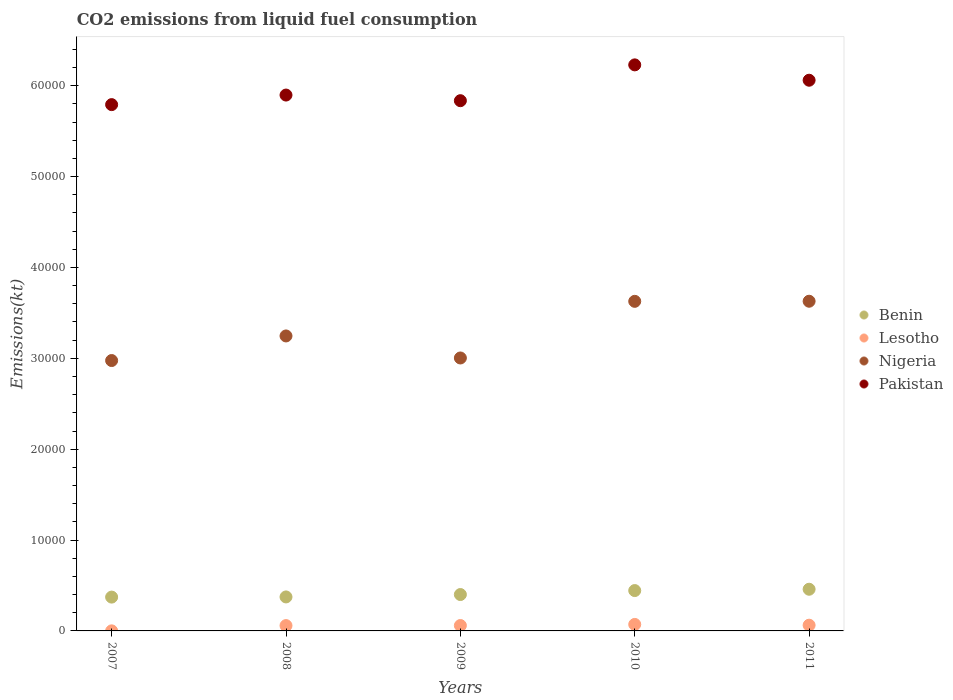How many different coloured dotlines are there?
Offer a very short reply. 4. Is the number of dotlines equal to the number of legend labels?
Offer a very short reply. Yes. What is the amount of CO2 emitted in Benin in 2011?
Give a very brief answer. 4587.42. Across all years, what is the maximum amount of CO2 emitted in Benin?
Keep it short and to the point. 4587.42. Across all years, what is the minimum amount of CO2 emitted in Benin?
Your answer should be compact. 3722.01. In which year was the amount of CO2 emitted in Nigeria maximum?
Offer a very short reply. 2011. What is the total amount of CO2 emitted in Benin in the graph?
Offer a terse response. 2.05e+04. What is the difference between the amount of CO2 emitted in Nigeria in 2009 and that in 2010?
Provide a short and direct response. -6233.9. What is the difference between the amount of CO2 emitted in Benin in 2010 and the amount of CO2 emitted in Nigeria in 2008?
Ensure brevity in your answer.  -2.80e+04. What is the average amount of CO2 emitted in Lesotho per year?
Provide a succinct answer. 506.78. In the year 2011, what is the difference between the amount of CO2 emitted in Nigeria and amount of CO2 emitted in Benin?
Your answer should be compact. 3.17e+04. In how many years, is the amount of CO2 emitted in Pakistan greater than 32000 kt?
Provide a succinct answer. 5. What is the ratio of the amount of CO2 emitted in Benin in 2007 to that in 2008?
Provide a short and direct response. 1. Is the difference between the amount of CO2 emitted in Nigeria in 2008 and 2009 greater than the difference between the amount of CO2 emitted in Benin in 2008 and 2009?
Give a very brief answer. Yes. What is the difference between the highest and the second highest amount of CO2 emitted in Lesotho?
Give a very brief answer. 84.34. What is the difference between the highest and the lowest amount of CO2 emitted in Pakistan?
Provide a short and direct response. 4374.73. Is the sum of the amount of CO2 emitted in Pakistan in 2008 and 2009 greater than the maximum amount of CO2 emitted in Nigeria across all years?
Offer a terse response. Yes. Is it the case that in every year, the sum of the amount of CO2 emitted in Pakistan and amount of CO2 emitted in Lesotho  is greater than the amount of CO2 emitted in Nigeria?
Ensure brevity in your answer.  Yes. Is the amount of CO2 emitted in Pakistan strictly greater than the amount of CO2 emitted in Nigeria over the years?
Keep it short and to the point. Yes. Are the values on the major ticks of Y-axis written in scientific E-notation?
Make the answer very short. No. Where does the legend appear in the graph?
Offer a very short reply. Center right. How are the legend labels stacked?
Make the answer very short. Vertical. What is the title of the graph?
Provide a short and direct response. CO2 emissions from liquid fuel consumption. What is the label or title of the Y-axis?
Provide a succinct answer. Emissions(kt). What is the Emissions(kt) of Benin in 2007?
Your answer should be compact. 3722.01. What is the Emissions(kt) of Lesotho in 2007?
Make the answer very short. 7.33. What is the Emissions(kt) in Nigeria in 2007?
Make the answer very short. 2.98e+04. What is the Emissions(kt) of Pakistan in 2007?
Keep it short and to the point. 5.79e+04. What is the Emissions(kt) of Benin in 2008?
Your answer should be compact. 3740.34. What is the Emissions(kt) in Lesotho in 2008?
Your response must be concise. 586.72. What is the Emissions(kt) in Nigeria in 2008?
Offer a very short reply. 3.25e+04. What is the Emissions(kt) in Pakistan in 2008?
Your response must be concise. 5.90e+04. What is the Emissions(kt) of Benin in 2009?
Offer a very short reply. 4004.36. What is the Emissions(kt) of Lesotho in 2009?
Offer a terse response. 594.05. What is the Emissions(kt) of Nigeria in 2009?
Your answer should be very brief. 3.00e+04. What is the Emissions(kt) in Pakistan in 2009?
Offer a terse response. 5.84e+04. What is the Emissions(kt) in Benin in 2010?
Give a very brief answer. 4440.74. What is the Emissions(kt) of Lesotho in 2010?
Make the answer very short. 715.07. What is the Emissions(kt) of Nigeria in 2010?
Make the answer very short. 3.63e+04. What is the Emissions(kt) of Pakistan in 2010?
Offer a very short reply. 6.23e+04. What is the Emissions(kt) of Benin in 2011?
Provide a short and direct response. 4587.42. What is the Emissions(kt) in Lesotho in 2011?
Provide a succinct answer. 630.72. What is the Emissions(kt) of Nigeria in 2011?
Your answer should be very brief. 3.63e+04. What is the Emissions(kt) in Pakistan in 2011?
Your response must be concise. 6.06e+04. Across all years, what is the maximum Emissions(kt) in Benin?
Offer a terse response. 4587.42. Across all years, what is the maximum Emissions(kt) of Lesotho?
Give a very brief answer. 715.07. Across all years, what is the maximum Emissions(kt) of Nigeria?
Provide a short and direct response. 3.63e+04. Across all years, what is the maximum Emissions(kt) of Pakistan?
Your answer should be very brief. 6.23e+04. Across all years, what is the minimum Emissions(kt) of Benin?
Give a very brief answer. 3722.01. Across all years, what is the minimum Emissions(kt) of Lesotho?
Ensure brevity in your answer.  7.33. Across all years, what is the minimum Emissions(kt) in Nigeria?
Offer a terse response. 2.98e+04. Across all years, what is the minimum Emissions(kt) in Pakistan?
Your answer should be very brief. 5.79e+04. What is the total Emissions(kt) in Benin in the graph?
Keep it short and to the point. 2.05e+04. What is the total Emissions(kt) of Lesotho in the graph?
Your answer should be very brief. 2533.9. What is the total Emissions(kt) of Nigeria in the graph?
Your response must be concise. 1.65e+05. What is the total Emissions(kt) in Pakistan in the graph?
Your answer should be compact. 2.98e+05. What is the difference between the Emissions(kt) in Benin in 2007 and that in 2008?
Give a very brief answer. -18.34. What is the difference between the Emissions(kt) of Lesotho in 2007 and that in 2008?
Offer a very short reply. -579.39. What is the difference between the Emissions(kt) in Nigeria in 2007 and that in 2008?
Make the answer very short. -2706.25. What is the difference between the Emissions(kt) of Pakistan in 2007 and that in 2008?
Your response must be concise. -1052.43. What is the difference between the Emissions(kt) in Benin in 2007 and that in 2009?
Your response must be concise. -282.36. What is the difference between the Emissions(kt) of Lesotho in 2007 and that in 2009?
Make the answer very short. -586.72. What is the difference between the Emissions(kt) of Nigeria in 2007 and that in 2009?
Your answer should be very brief. -282.36. What is the difference between the Emissions(kt) in Pakistan in 2007 and that in 2009?
Offer a very short reply. -432.71. What is the difference between the Emissions(kt) of Benin in 2007 and that in 2010?
Your response must be concise. -718.73. What is the difference between the Emissions(kt) in Lesotho in 2007 and that in 2010?
Provide a short and direct response. -707.73. What is the difference between the Emissions(kt) of Nigeria in 2007 and that in 2010?
Your answer should be compact. -6516.26. What is the difference between the Emissions(kt) in Pakistan in 2007 and that in 2010?
Your response must be concise. -4374.73. What is the difference between the Emissions(kt) in Benin in 2007 and that in 2011?
Provide a succinct answer. -865.41. What is the difference between the Emissions(kt) of Lesotho in 2007 and that in 2011?
Your answer should be very brief. -623.39. What is the difference between the Emissions(kt) in Nigeria in 2007 and that in 2011?
Give a very brief answer. -6527.26. What is the difference between the Emissions(kt) in Pakistan in 2007 and that in 2011?
Keep it short and to the point. -2684.24. What is the difference between the Emissions(kt) of Benin in 2008 and that in 2009?
Give a very brief answer. -264.02. What is the difference between the Emissions(kt) in Lesotho in 2008 and that in 2009?
Ensure brevity in your answer.  -7.33. What is the difference between the Emissions(kt) in Nigeria in 2008 and that in 2009?
Your response must be concise. 2423.89. What is the difference between the Emissions(kt) of Pakistan in 2008 and that in 2009?
Keep it short and to the point. 619.72. What is the difference between the Emissions(kt) in Benin in 2008 and that in 2010?
Ensure brevity in your answer.  -700.4. What is the difference between the Emissions(kt) of Lesotho in 2008 and that in 2010?
Your answer should be compact. -128.34. What is the difference between the Emissions(kt) in Nigeria in 2008 and that in 2010?
Your answer should be compact. -3810.01. What is the difference between the Emissions(kt) of Pakistan in 2008 and that in 2010?
Your answer should be very brief. -3322.3. What is the difference between the Emissions(kt) of Benin in 2008 and that in 2011?
Your answer should be compact. -847.08. What is the difference between the Emissions(kt) of Lesotho in 2008 and that in 2011?
Provide a short and direct response. -44. What is the difference between the Emissions(kt) of Nigeria in 2008 and that in 2011?
Make the answer very short. -3821.01. What is the difference between the Emissions(kt) in Pakistan in 2008 and that in 2011?
Your response must be concise. -1631.82. What is the difference between the Emissions(kt) in Benin in 2009 and that in 2010?
Ensure brevity in your answer.  -436.37. What is the difference between the Emissions(kt) of Lesotho in 2009 and that in 2010?
Provide a succinct answer. -121.01. What is the difference between the Emissions(kt) in Nigeria in 2009 and that in 2010?
Your answer should be very brief. -6233.9. What is the difference between the Emissions(kt) of Pakistan in 2009 and that in 2010?
Provide a short and direct response. -3942.03. What is the difference between the Emissions(kt) of Benin in 2009 and that in 2011?
Offer a very short reply. -583.05. What is the difference between the Emissions(kt) of Lesotho in 2009 and that in 2011?
Offer a very short reply. -36.67. What is the difference between the Emissions(kt) in Nigeria in 2009 and that in 2011?
Offer a terse response. -6244.9. What is the difference between the Emissions(kt) of Pakistan in 2009 and that in 2011?
Offer a terse response. -2251.54. What is the difference between the Emissions(kt) of Benin in 2010 and that in 2011?
Provide a succinct answer. -146.68. What is the difference between the Emissions(kt) of Lesotho in 2010 and that in 2011?
Keep it short and to the point. 84.34. What is the difference between the Emissions(kt) of Nigeria in 2010 and that in 2011?
Offer a terse response. -11. What is the difference between the Emissions(kt) of Pakistan in 2010 and that in 2011?
Offer a very short reply. 1690.49. What is the difference between the Emissions(kt) of Benin in 2007 and the Emissions(kt) of Lesotho in 2008?
Provide a succinct answer. 3135.28. What is the difference between the Emissions(kt) in Benin in 2007 and the Emissions(kt) in Nigeria in 2008?
Your answer should be compact. -2.87e+04. What is the difference between the Emissions(kt) of Benin in 2007 and the Emissions(kt) of Pakistan in 2008?
Give a very brief answer. -5.53e+04. What is the difference between the Emissions(kt) of Lesotho in 2007 and the Emissions(kt) of Nigeria in 2008?
Offer a terse response. -3.25e+04. What is the difference between the Emissions(kt) of Lesotho in 2007 and the Emissions(kt) of Pakistan in 2008?
Your answer should be compact. -5.90e+04. What is the difference between the Emissions(kt) of Nigeria in 2007 and the Emissions(kt) of Pakistan in 2008?
Keep it short and to the point. -2.92e+04. What is the difference between the Emissions(kt) in Benin in 2007 and the Emissions(kt) in Lesotho in 2009?
Provide a short and direct response. 3127.95. What is the difference between the Emissions(kt) of Benin in 2007 and the Emissions(kt) of Nigeria in 2009?
Your response must be concise. -2.63e+04. What is the difference between the Emissions(kt) in Benin in 2007 and the Emissions(kt) in Pakistan in 2009?
Provide a short and direct response. -5.46e+04. What is the difference between the Emissions(kt) in Lesotho in 2007 and the Emissions(kt) in Nigeria in 2009?
Give a very brief answer. -3.00e+04. What is the difference between the Emissions(kt) of Lesotho in 2007 and the Emissions(kt) of Pakistan in 2009?
Keep it short and to the point. -5.83e+04. What is the difference between the Emissions(kt) in Nigeria in 2007 and the Emissions(kt) in Pakistan in 2009?
Give a very brief answer. -2.86e+04. What is the difference between the Emissions(kt) of Benin in 2007 and the Emissions(kt) of Lesotho in 2010?
Your answer should be very brief. 3006.94. What is the difference between the Emissions(kt) of Benin in 2007 and the Emissions(kt) of Nigeria in 2010?
Ensure brevity in your answer.  -3.26e+04. What is the difference between the Emissions(kt) in Benin in 2007 and the Emissions(kt) in Pakistan in 2010?
Offer a terse response. -5.86e+04. What is the difference between the Emissions(kt) in Lesotho in 2007 and the Emissions(kt) in Nigeria in 2010?
Your answer should be compact. -3.63e+04. What is the difference between the Emissions(kt) in Lesotho in 2007 and the Emissions(kt) in Pakistan in 2010?
Make the answer very short. -6.23e+04. What is the difference between the Emissions(kt) in Nigeria in 2007 and the Emissions(kt) in Pakistan in 2010?
Keep it short and to the point. -3.25e+04. What is the difference between the Emissions(kt) of Benin in 2007 and the Emissions(kt) of Lesotho in 2011?
Provide a short and direct response. 3091.28. What is the difference between the Emissions(kt) of Benin in 2007 and the Emissions(kt) of Nigeria in 2011?
Give a very brief answer. -3.26e+04. What is the difference between the Emissions(kt) in Benin in 2007 and the Emissions(kt) in Pakistan in 2011?
Your response must be concise. -5.69e+04. What is the difference between the Emissions(kt) of Lesotho in 2007 and the Emissions(kt) of Nigeria in 2011?
Ensure brevity in your answer.  -3.63e+04. What is the difference between the Emissions(kt) of Lesotho in 2007 and the Emissions(kt) of Pakistan in 2011?
Make the answer very short. -6.06e+04. What is the difference between the Emissions(kt) in Nigeria in 2007 and the Emissions(kt) in Pakistan in 2011?
Keep it short and to the point. -3.09e+04. What is the difference between the Emissions(kt) of Benin in 2008 and the Emissions(kt) of Lesotho in 2009?
Keep it short and to the point. 3146.29. What is the difference between the Emissions(kt) of Benin in 2008 and the Emissions(kt) of Nigeria in 2009?
Provide a succinct answer. -2.63e+04. What is the difference between the Emissions(kt) of Benin in 2008 and the Emissions(kt) of Pakistan in 2009?
Your answer should be very brief. -5.46e+04. What is the difference between the Emissions(kt) in Lesotho in 2008 and the Emissions(kt) in Nigeria in 2009?
Your answer should be very brief. -2.95e+04. What is the difference between the Emissions(kt) in Lesotho in 2008 and the Emissions(kt) in Pakistan in 2009?
Your answer should be very brief. -5.78e+04. What is the difference between the Emissions(kt) in Nigeria in 2008 and the Emissions(kt) in Pakistan in 2009?
Your response must be concise. -2.59e+04. What is the difference between the Emissions(kt) of Benin in 2008 and the Emissions(kt) of Lesotho in 2010?
Give a very brief answer. 3025.28. What is the difference between the Emissions(kt) of Benin in 2008 and the Emissions(kt) of Nigeria in 2010?
Your answer should be very brief. -3.25e+04. What is the difference between the Emissions(kt) in Benin in 2008 and the Emissions(kt) in Pakistan in 2010?
Provide a succinct answer. -5.86e+04. What is the difference between the Emissions(kt) in Lesotho in 2008 and the Emissions(kt) in Nigeria in 2010?
Your response must be concise. -3.57e+04. What is the difference between the Emissions(kt) in Lesotho in 2008 and the Emissions(kt) in Pakistan in 2010?
Your answer should be very brief. -6.17e+04. What is the difference between the Emissions(kt) in Nigeria in 2008 and the Emissions(kt) in Pakistan in 2010?
Offer a terse response. -2.98e+04. What is the difference between the Emissions(kt) of Benin in 2008 and the Emissions(kt) of Lesotho in 2011?
Your answer should be very brief. 3109.62. What is the difference between the Emissions(kt) in Benin in 2008 and the Emissions(kt) in Nigeria in 2011?
Your answer should be compact. -3.25e+04. What is the difference between the Emissions(kt) of Benin in 2008 and the Emissions(kt) of Pakistan in 2011?
Your response must be concise. -5.69e+04. What is the difference between the Emissions(kt) in Lesotho in 2008 and the Emissions(kt) in Nigeria in 2011?
Keep it short and to the point. -3.57e+04. What is the difference between the Emissions(kt) of Lesotho in 2008 and the Emissions(kt) of Pakistan in 2011?
Your answer should be compact. -6.00e+04. What is the difference between the Emissions(kt) in Nigeria in 2008 and the Emissions(kt) in Pakistan in 2011?
Give a very brief answer. -2.81e+04. What is the difference between the Emissions(kt) in Benin in 2009 and the Emissions(kt) in Lesotho in 2010?
Provide a succinct answer. 3289.3. What is the difference between the Emissions(kt) of Benin in 2009 and the Emissions(kt) of Nigeria in 2010?
Make the answer very short. -3.23e+04. What is the difference between the Emissions(kt) in Benin in 2009 and the Emissions(kt) in Pakistan in 2010?
Ensure brevity in your answer.  -5.83e+04. What is the difference between the Emissions(kt) in Lesotho in 2009 and the Emissions(kt) in Nigeria in 2010?
Provide a short and direct response. -3.57e+04. What is the difference between the Emissions(kt) of Lesotho in 2009 and the Emissions(kt) of Pakistan in 2010?
Make the answer very short. -6.17e+04. What is the difference between the Emissions(kt) of Nigeria in 2009 and the Emissions(kt) of Pakistan in 2010?
Give a very brief answer. -3.23e+04. What is the difference between the Emissions(kt) in Benin in 2009 and the Emissions(kt) in Lesotho in 2011?
Ensure brevity in your answer.  3373.64. What is the difference between the Emissions(kt) of Benin in 2009 and the Emissions(kt) of Nigeria in 2011?
Offer a very short reply. -3.23e+04. What is the difference between the Emissions(kt) of Benin in 2009 and the Emissions(kt) of Pakistan in 2011?
Your answer should be compact. -5.66e+04. What is the difference between the Emissions(kt) in Lesotho in 2009 and the Emissions(kt) in Nigeria in 2011?
Your answer should be very brief. -3.57e+04. What is the difference between the Emissions(kt) in Lesotho in 2009 and the Emissions(kt) in Pakistan in 2011?
Give a very brief answer. -6.00e+04. What is the difference between the Emissions(kt) in Nigeria in 2009 and the Emissions(kt) in Pakistan in 2011?
Your response must be concise. -3.06e+04. What is the difference between the Emissions(kt) in Benin in 2010 and the Emissions(kt) in Lesotho in 2011?
Your answer should be compact. 3810.01. What is the difference between the Emissions(kt) in Benin in 2010 and the Emissions(kt) in Nigeria in 2011?
Your answer should be very brief. -3.18e+04. What is the difference between the Emissions(kt) of Benin in 2010 and the Emissions(kt) of Pakistan in 2011?
Your response must be concise. -5.62e+04. What is the difference between the Emissions(kt) in Lesotho in 2010 and the Emissions(kt) in Nigeria in 2011?
Your answer should be very brief. -3.56e+04. What is the difference between the Emissions(kt) of Lesotho in 2010 and the Emissions(kt) of Pakistan in 2011?
Keep it short and to the point. -5.99e+04. What is the difference between the Emissions(kt) of Nigeria in 2010 and the Emissions(kt) of Pakistan in 2011?
Your answer should be very brief. -2.43e+04. What is the average Emissions(kt) in Benin per year?
Offer a very short reply. 4098.97. What is the average Emissions(kt) in Lesotho per year?
Make the answer very short. 506.78. What is the average Emissions(kt) of Nigeria per year?
Your answer should be very brief. 3.30e+04. What is the average Emissions(kt) of Pakistan per year?
Your answer should be compact. 5.96e+04. In the year 2007, what is the difference between the Emissions(kt) of Benin and Emissions(kt) of Lesotho?
Offer a very short reply. 3714.67. In the year 2007, what is the difference between the Emissions(kt) in Benin and Emissions(kt) in Nigeria?
Give a very brief answer. -2.60e+04. In the year 2007, what is the difference between the Emissions(kt) in Benin and Emissions(kt) in Pakistan?
Your answer should be compact. -5.42e+04. In the year 2007, what is the difference between the Emissions(kt) of Lesotho and Emissions(kt) of Nigeria?
Your response must be concise. -2.98e+04. In the year 2007, what is the difference between the Emissions(kt) in Lesotho and Emissions(kt) in Pakistan?
Offer a very short reply. -5.79e+04. In the year 2007, what is the difference between the Emissions(kt) of Nigeria and Emissions(kt) of Pakistan?
Offer a very short reply. -2.82e+04. In the year 2008, what is the difference between the Emissions(kt) of Benin and Emissions(kt) of Lesotho?
Make the answer very short. 3153.62. In the year 2008, what is the difference between the Emissions(kt) in Benin and Emissions(kt) in Nigeria?
Your response must be concise. -2.87e+04. In the year 2008, what is the difference between the Emissions(kt) in Benin and Emissions(kt) in Pakistan?
Provide a short and direct response. -5.52e+04. In the year 2008, what is the difference between the Emissions(kt) of Lesotho and Emissions(kt) of Nigeria?
Your response must be concise. -3.19e+04. In the year 2008, what is the difference between the Emissions(kt) in Lesotho and Emissions(kt) in Pakistan?
Your response must be concise. -5.84e+04. In the year 2008, what is the difference between the Emissions(kt) in Nigeria and Emissions(kt) in Pakistan?
Offer a terse response. -2.65e+04. In the year 2009, what is the difference between the Emissions(kt) in Benin and Emissions(kt) in Lesotho?
Offer a very short reply. 3410.31. In the year 2009, what is the difference between the Emissions(kt) in Benin and Emissions(kt) in Nigeria?
Offer a very short reply. -2.60e+04. In the year 2009, what is the difference between the Emissions(kt) of Benin and Emissions(kt) of Pakistan?
Keep it short and to the point. -5.44e+04. In the year 2009, what is the difference between the Emissions(kt) in Lesotho and Emissions(kt) in Nigeria?
Offer a terse response. -2.94e+04. In the year 2009, what is the difference between the Emissions(kt) of Lesotho and Emissions(kt) of Pakistan?
Keep it short and to the point. -5.78e+04. In the year 2009, what is the difference between the Emissions(kt) of Nigeria and Emissions(kt) of Pakistan?
Give a very brief answer. -2.83e+04. In the year 2010, what is the difference between the Emissions(kt) of Benin and Emissions(kt) of Lesotho?
Offer a very short reply. 3725.67. In the year 2010, what is the difference between the Emissions(kt) in Benin and Emissions(kt) in Nigeria?
Keep it short and to the point. -3.18e+04. In the year 2010, what is the difference between the Emissions(kt) of Benin and Emissions(kt) of Pakistan?
Provide a short and direct response. -5.79e+04. In the year 2010, what is the difference between the Emissions(kt) in Lesotho and Emissions(kt) in Nigeria?
Your answer should be compact. -3.56e+04. In the year 2010, what is the difference between the Emissions(kt) of Lesotho and Emissions(kt) of Pakistan?
Offer a terse response. -6.16e+04. In the year 2010, what is the difference between the Emissions(kt) of Nigeria and Emissions(kt) of Pakistan?
Provide a short and direct response. -2.60e+04. In the year 2011, what is the difference between the Emissions(kt) of Benin and Emissions(kt) of Lesotho?
Offer a terse response. 3956.69. In the year 2011, what is the difference between the Emissions(kt) of Benin and Emissions(kt) of Nigeria?
Keep it short and to the point. -3.17e+04. In the year 2011, what is the difference between the Emissions(kt) of Benin and Emissions(kt) of Pakistan?
Provide a short and direct response. -5.60e+04. In the year 2011, what is the difference between the Emissions(kt) in Lesotho and Emissions(kt) in Nigeria?
Your response must be concise. -3.57e+04. In the year 2011, what is the difference between the Emissions(kt) of Lesotho and Emissions(kt) of Pakistan?
Your response must be concise. -6.00e+04. In the year 2011, what is the difference between the Emissions(kt) of Nigeria and Emissions(kt) of Pakistan?
Provide a short and direct response. -2.43e+04. What is the ratio of the Emissions(kt) of Lesotho in 2007 to that in 2008?
Provide a succinct answer. 0.01. What is the ratio of the Emissions(kt) of Nigeria in 2007 to that in 2008?
Offer a terse response. 0.92. What is the ratio of the Emissions(kt) in Pakistan in 2007 to that in 2008?
Offer a very short reply. 0.98. What is the ratio of the Emissions(kt) of Benin in 2007 to that in 2009?
Your answer should be very brief. 0.93. What is the ratio of the Emissions(kt) of Lesotho in 2007 to that in 2009?
Offer a very short reply. 0.01. What is the ratio of the Emissions(kt) of Nigeria in 2007 to that in 2009?
Give a very brief answer. 0.99. What is the ratio of the Emissions(kt) in Pakistan in 2007 to that in 2009?
Keep it short and to the point. 0.99. What is the ratio of the Emissions(kt) of Benin in 2007 to that in 2010?
Offer a terse response. 0.84. What is the ratio of the Emissions(kt) in Lesotho in 2007 to that in 2010?
Offer a terse response. 0.01. What is the ratio of the Emissions(kt) of Nigeria in 2007 to that in 2010?
Offer a terse response. 0.82. What is the ratio of the Emissions(kt) in Pakistan in 2007 to that in 2010?
Your response must be concise. 0.93. What is the ratio of the Emissions(kt) in Benin in 2007 to that in 2011?
Keep it short and to the point. 0.81. What is the ratio of the Emissions(kt) of Lesotho in 2007 to that in 2011?
Provide a short and direct response. 0.01. What is the ratio of the Emissions(kt) in Nigeria in 2007 to that in 2011?
Ensure brevity in your answer.  0.82. What is the ratio of the Emissions(kt) in Pakistan in 2007 to that in 2011?
Keep it short and to the point. 0.96. What is the ratio of the Emissions(kt) of Benin in 2008 to that in 2009?
Keep it short and to the point. 0.93. What is the ratio of the Emissions(kt) in Nigeria in 2008 to that in 2009?
Make the answer very short. 1.08. What is the ratio of the Emissions(kt) in Pakistan in 2008 to that in 2009?
Ensure brevity in your answer.  1.01. What is the ratio of the Emissions(kt) of Benin in 2008 to that in 2010?
Your answer should be compact. 0.84. What is the ratio of the Emissions(kt) in Lesotho in 2008 to that in 2010?
Provide a succinct answer. 0.82. What is the ratio of the Emissions(kt) of Nigeria in 2008 to that in 2010?
Your answer should be compact. 0.9. What is the ratio of the Emissions(kt) of Pakistan in 2008 to that in 2010?
Ensure brevity in your answer.  0.95. What is the ratio of the Emissions(kt) of Benin in 2008 to that in 2011?
Your answer should be very brief. 0.82. What is the ratio of the Emissions(kt) of Lesotho in 2008 to that in 2011?
Provide a succinct answer. 0.93. What is the ratio of the Emissions(kt) in Nigeria in 2008 to that in 2011?
Offer a very short reply. 0.89. What is the ratio of the Emissions(kt) of Pakistan in 2008 to that in 2011?
Give a very brief answer. 0.97. What is the ratio of the Emissions(kt) in Benin in 2009 to that in 2010?
Your response must be concise. 0.9. What is the ratio of the Emissions(kt) in Lesotho in 2009 to that in 2010?
Offer a terse response. 0.83. What is the ratio of the Emissions(kt) of Nigeria in 2009 to that in 2010?
Offer a terse response. 0.83. What is the ratio of the Emissions(kt) of Pakistan in 2009 to that in 2010?
Offer a very short reply. 0.94. What is the ratio of the Emissions(kt) in Benin in 2009 to that in 2011?
Your answer should be compact. 0.87. What is the ratio of the Emissions(kt) in Lesotho in 2009 to that in 2011?
Provide a succinct answer. 0.94. What is the ratio of the Emissions(kt) of Nigeria in 2009 to that in 2011?
Offer a very short reply. 0.83. What is the ratio of the Emissions(kt) in Pakistan in 2009 to that in 2011?
Ensure brevity in your answer.  0.96. What is the ratio of the Emissions(kt) of Lesotho in 2010 to that in 2011?
Offer a terse response. 1.13. What is the ratio of the Emissions(kt) in Nigeria in 2010 to that in 2011?
Your response must be concise. 1. What is the ratio of the Emissions(kt) of Pakistan in 2010 to that in 2011?
Give a very brief answer. 1.03. What is the difference between the highest and the second highest Emissions(kt) of Benin?
Ensure brevity in your answer.  146.68. What is the difference between the highest and the second highest Emissions(kt) in Lesotho?
Offer a very short reply. 84.34. What is the difference between the highest and the second highest Emissions(kt) of Nigeria?
Ensure brevity in your answer.  11. What is the difference between the highest and the second highest Emissions(kt) in Pakistan?
Offer a very short reply. 1690.49. What is the difference between the highest and the lowest Emissions(kt) in Benin?
Provide a short and direct response. 865.41. What is the difference between the highest and the lowest Emissions(kt) of Lesotho?
Provide a short and direct response. 707.73. What is the difference between the highest and the lowest Emissions(kt) in Nigeria?
Your answer should be compact. 6527.26. What is the difference between the highest and the lowest Emissions(kt) of Pakistan?
Give a very brief answer. 4374.73. 